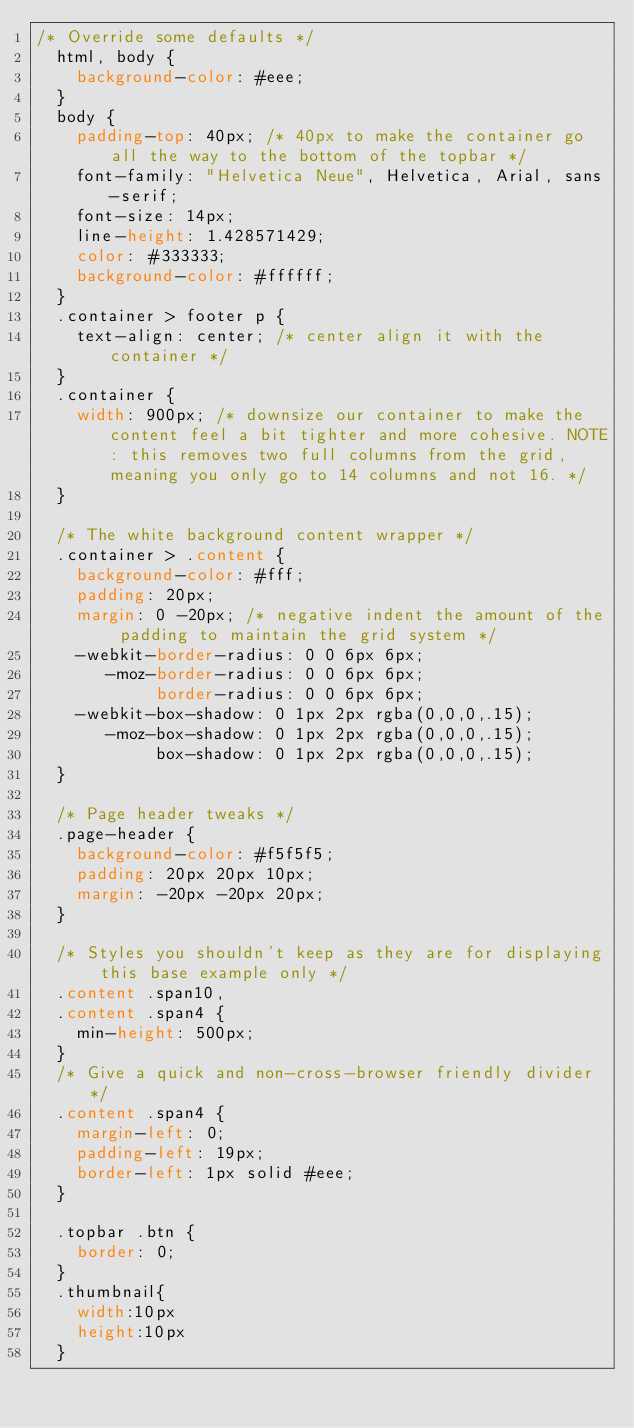Convert code to text. <code><loc_0><loc_0><loc_500><loc_500><_CSS_>/* Override some defaults */
  html, body {
    background-color: #eee;
  }
  body {
    padding-top: 40px; /* 40px to make the container go all the way to the bottom of the topbar */
	font-family: "Helvetica Neue", Helvetica, Arial, sans-serif;
	font-size: 14px;
	line-height: 1.428571429;
	color: #333333;
	background-color: #ffffff;
  }
  .container > footer p {
    text-align: center; /* center align it with the container */
  }
  .container {
    width: 900px; /* downsize our container to make the content feel a bit tighter and more cohesive. NOTE: this removes two full columns from the grid, meaning you only go to 14 columns and not 16. */
  }

  /* The white background content wrapper */
  .container > .content {
    background-color: #fff;
    padding: 20px;
    margin: 0 -20px; /* negative indent the amount of the padding to maintain the grid system */
    -webkit-border-radius: 0 0 6px 6px;
       -moz-border-radius: 0 0 6px 6px;
            border-radius: 0 0 6px 6px;
    -webkit-box-shadow: 0 1px 2px rgba(0,0,0,.15);
       -moz-box-shadow: 0 1px 2px rgba(0,0,0,.15);
            box-shadow: 0 1px 2px rgba(0,0,0,.15);
  }

  /* Page header tweaks */
  .page-header {
    background-color: #f5f5f5;
    padding: 20px 20px 10px;
    margin: -20px -20px 20px;
  }

  /* Styles you shouldn't keep as they are for displaying this base example only */
  .content .span10,
  .content .span4 {
    min-height: 500px;
  }
  /* Give a quick and non-cross-browser friendly divider */
  .content .span4 {
    margin-left: 0;
    padding-left: 19px;
    border-left: 1px solid #eee;
  }

  .topbar .btn {
    border: 0;
  }
  .thumbnail{
	width:10px
	height:10px
  }</code> 